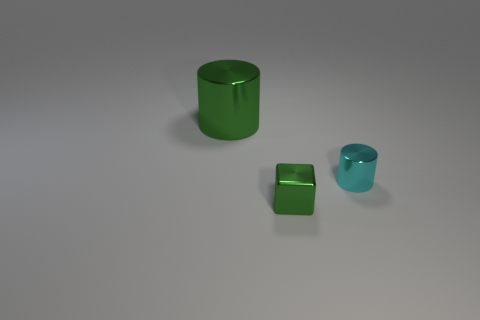Is the size of the cyan thing the same as the green cube in front of the big green thing? Upon closely examining the image, we can observe that the cyan object, which appears to be a smaller cylinder, has a height similar to that of the green cube; however, the cube’s width and depth seem to be slightly greater than the cyan object's diameter. 